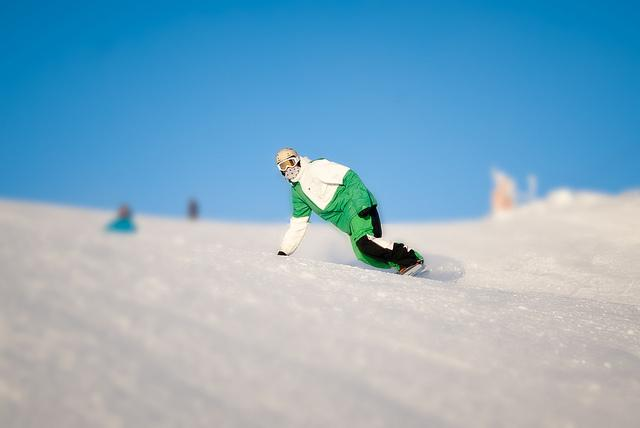The item the person is wearing on their face looks like what? Please explain your reasoning. gas mask. Each piece is very large and oversized and everything together resembles that type of equipment 